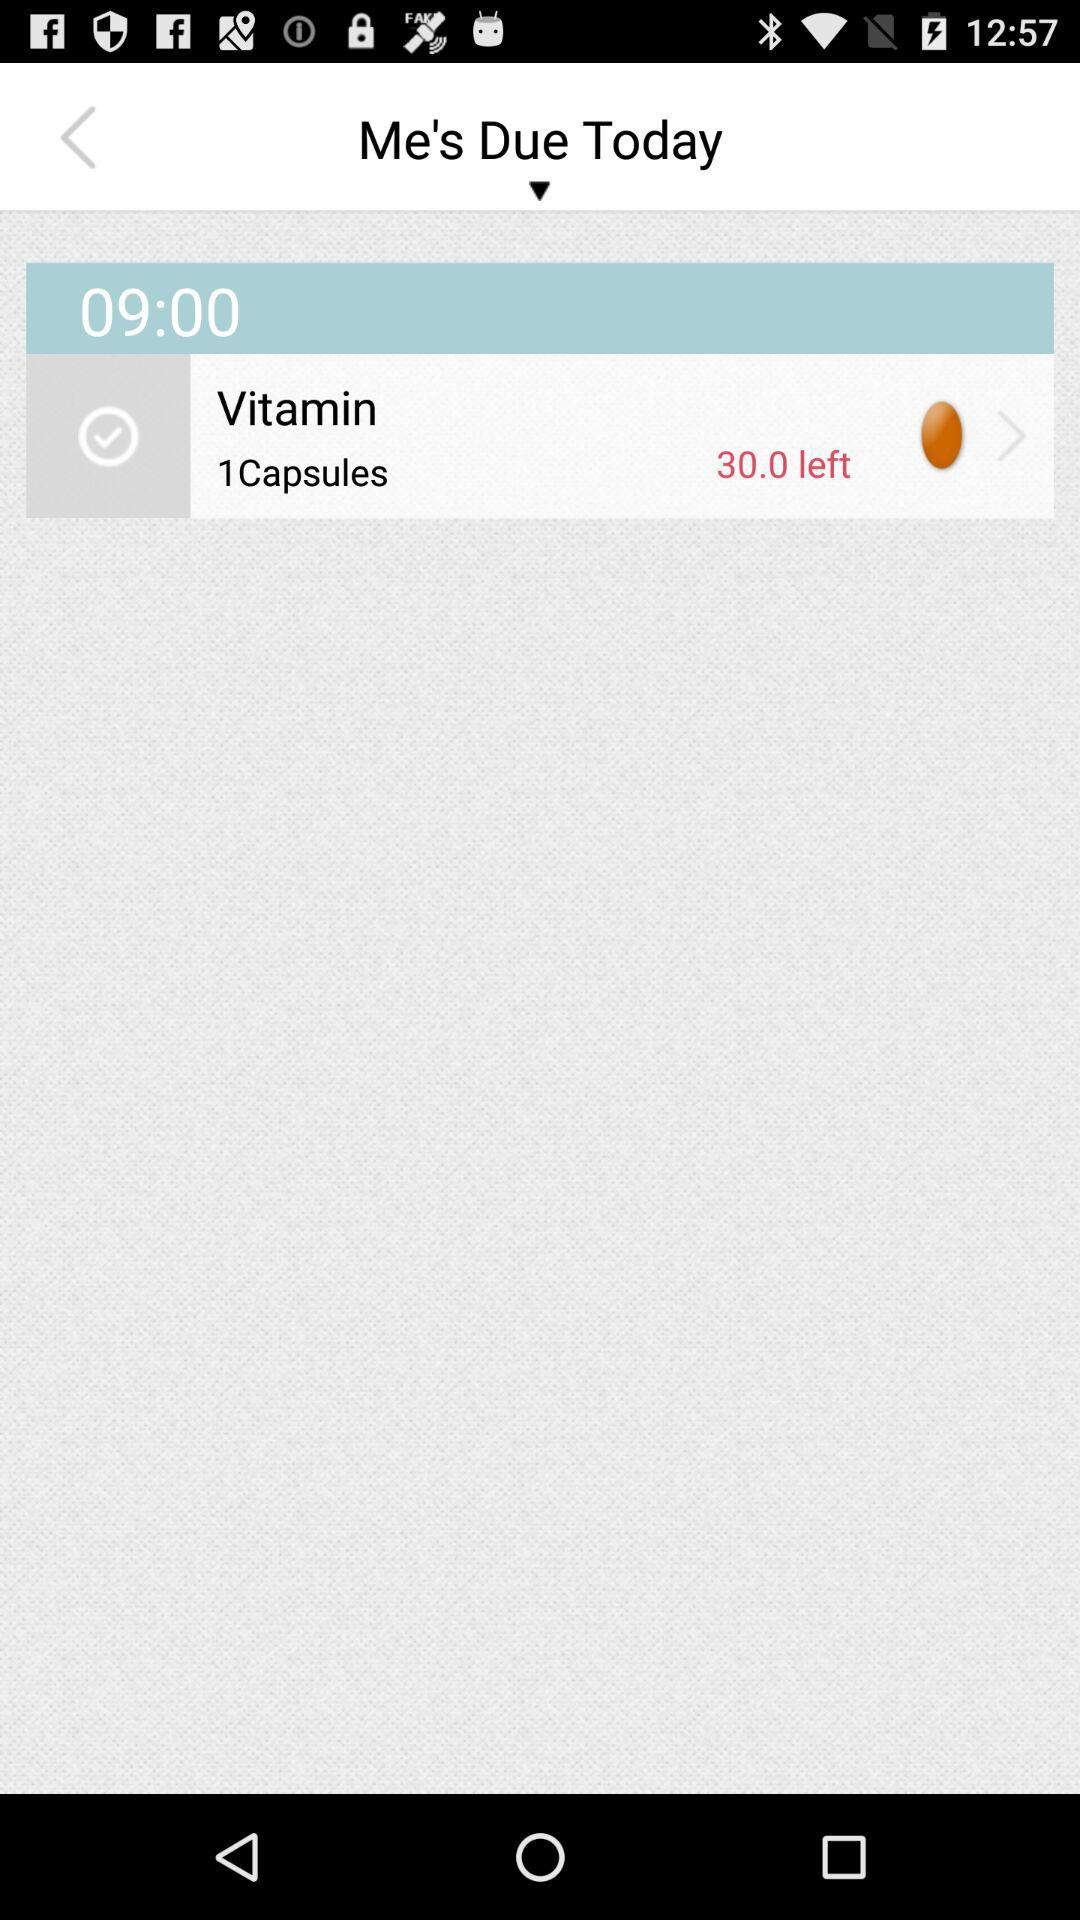What is the brand of the vitamin that is being taken?
When the provided information is insufficient, respond with <no answer>. <no answer> 